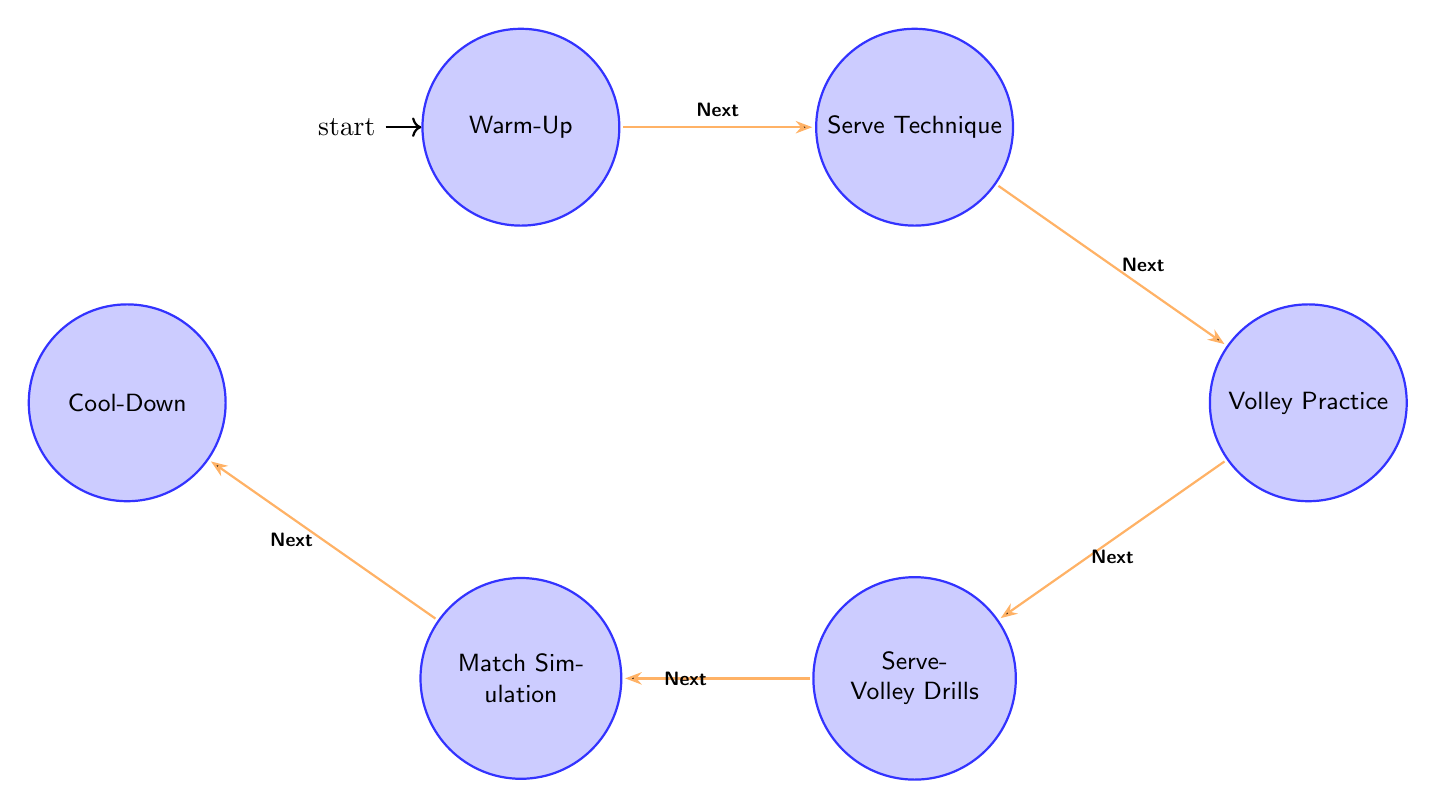What is the first state in the session structure? The diagram begins from the initial state, which is labeled as "Warm-Up." This state is indicated as the starting point of the session structure.
Answer: Warm-Up How many states are there in total? By counting all the distinct states listed in the diagram, we see six states: Warm-Up, Serve Technique, Volley Practice, Serve-Volley Drills, Match Simulation, and Cool-Down. This gives a total of six states.
Answer: 6 What action is included in the Serve Technique state? In the "Serve Technique" state, the actions listed are stance adjustment, ball toss practice, and serve motion drills. Any of these actions would be a correct response.
Answer: stance adjustment (or ball toss practice or serve motion drills) Which state comes after Volley Practice? Looking at the transitions, the "Volley Practice" state leads directly to the "Serve-Volley Drills" state as the next step in the session structure.
Answer: Serve-Volley Drills Is Cool-Down the last state in the structure? The "Cool-Down" is indeed the last state in the session structure, as it follows the "Match Simulation" state in the sequence provided in the diagram.
Answer: Yes What is the transition between Serve Technique and Volley Practice? The transition from "Serve Technique" to "Volley Practice" is indicated in the diagram by a labeled edge that states "Next," representing the flow of the session from one state to the next.
Answer: Next What actions are involved in the Match Simulation state? The "Match Simulation" state includes the actions serve-volleys, point construction, and game strategy review. Each of these actions reflects aspects of simulating a match situation.
Answer: serve-volleys (or point construction or game strategy review) How do the states flow from Warm-Up to Cool-Down? The states flow in a specific order: Warm-Up leads to Serve Technique, which goes to Volley Practice, then to Serve-Volley Drills, followed by Match Simulation, and finally ends at Cool-Down. This sequence is indicated through directed transitions in the diagram.
Answer: Warm-Up → Serve Technique → Volley Practice → Serve-Volley Drills → Match Simulation → Cool-Down What is the role of the Volley Practice state? The role of the "Volley Practice" state is to focus on specific skills related to volleying, including net positioning, reaction drills, and angle volleys, which are fundamental for effective play at the net.
Answer: Skill development 